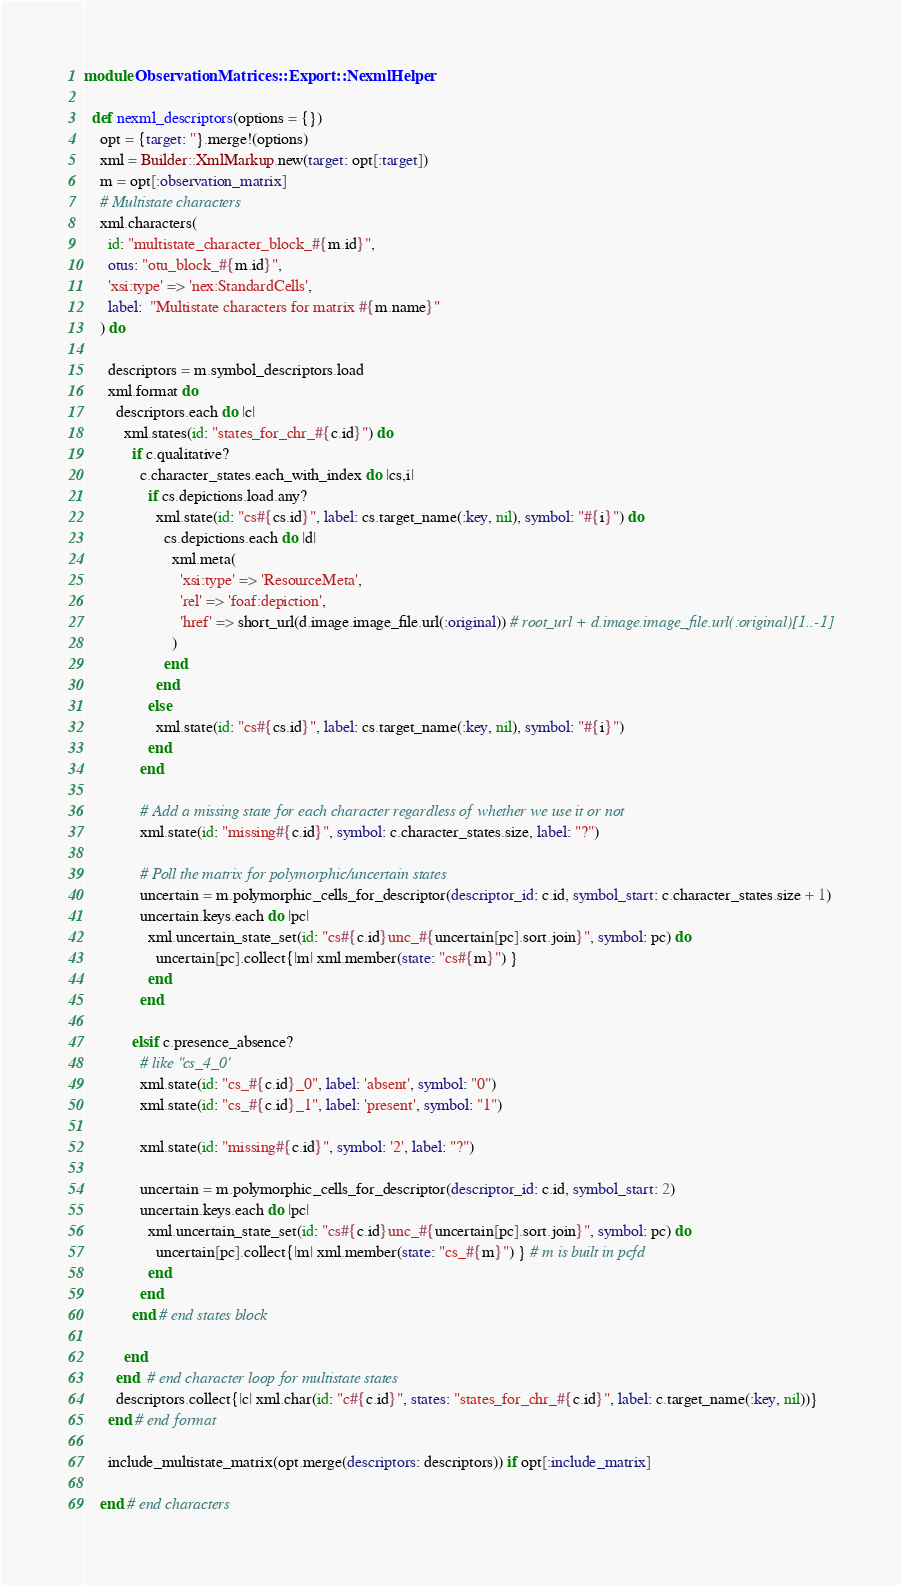<code> <loc_0><loc_0><loc_500><loc_500><_Ruby_>module ObservationMatrices::Export::NexmlHelper

  def nexml_descriptors(options = {})
    opt = {target: ''}.merge!(options)
    xml = Builder::XmlMarkup.new(target: opt[:target])
    m = opt[:observation_matrix]
    # Multistate characters
    xml.characters(
      id: "multistate_character_block_#{m.id}",
      otus: "otu_block_#{m.id}",
      'xsi:type' => 'nex:StandardCells',
      label:  "Multistate characters for matrix #{m.name}"
    ) do

      descriptors = m.symbol_descriptors.load
      xml.format do
        descriptors.each do |c|
          xml.states(id: "states_for_chr_#{c.id}") do
            if c.qualitative?
              c.character_states.each_with_index do |cs,i|
                if cs.depictions.load.any?
                  xml.state(id: "cs#{cs.id}", label: cs.target_name(:key, nil), symbol: "#{i}") do
                    cs.depictions.each do |d|
                      xml.meta(
                        'xsi:type' => 'ResourceMeta',
                        'rel' => 'foaf:depiction',
                        'href' => short_url(d.image.image_file.url(:original)) # root_url + d.image.image_file.url(:original)[1..-1]
                      )
                    end
                  end
                else
                  xml.state(id: "cs#{cs.id}", label: cs.target_name(:key, nil), symbol: "#{i}")
                end
              end

              # Add a missing state for each character regardless of whether we use it or not
              xml.state(id: "missing#{c.id}", symbol: c.character_states.size, label: "?")

              # Poll the matrix for polymorphic/uncertain states
              uncertain = m.polymorphic_cells_for_descriptor(descriptor_id: c.id, symbol_start: c.character_states.size + 1)
              uncertain.keys.each do |pc|
                xml.uncertain_state_set(id: "cs#{c.id}unc_#{uncertain[pc].sort.join}", symbol: pc) do
                  uncertain[pc].collect{|m| xml.member(state: "cs#{m}") }
                end
              end

            elsif c.presence_absence?
              # like "cs_4_0'
              xml.state(id: "cs_#{c.id}_0", label: 'absent', symbol: "0")
              xml.state(id: "cs_#{c.id}_1", label: 'present', symbol: "1")

              xml.state(id: "missing#{c.id}", symbol: '2', label: "?")

              uncertain = m.polymorphic_cells_for_descriptor(descriptor_id: c.id, symbol_start: 2)
              uncertain.keys.each do |pc|
                xml.uncertain_state_set(id: "cs#{c.id}unc_#{uncertain[pc].sort.join}", symbol: pc) do
                  uncertain[pc].collect{|m| xml.member(state: "cs_#{m}") } # m is built in pcfd
                end
              end
            end # end states block

          end
        end  # end character loop for multistate states
        descriptors.collect{|c| xml.char(id: "c#{c.id}", states: "states_for_chr_#{c.id}", label: c.target_name(:key, nil))}
      end # end format

      include_multistate_matrix(opt.merge(descriptors: descriptors)) if opt[:include_matrix]

    end # end characters
</code> 